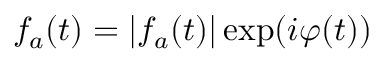Convert formula to latex. <formula><loc_0><loc_0><loc_500><loc_500>f _ { a } ( t ) = | f _ { a } ( t ) | \exp ( i \varphi ( t ) )</formula> 